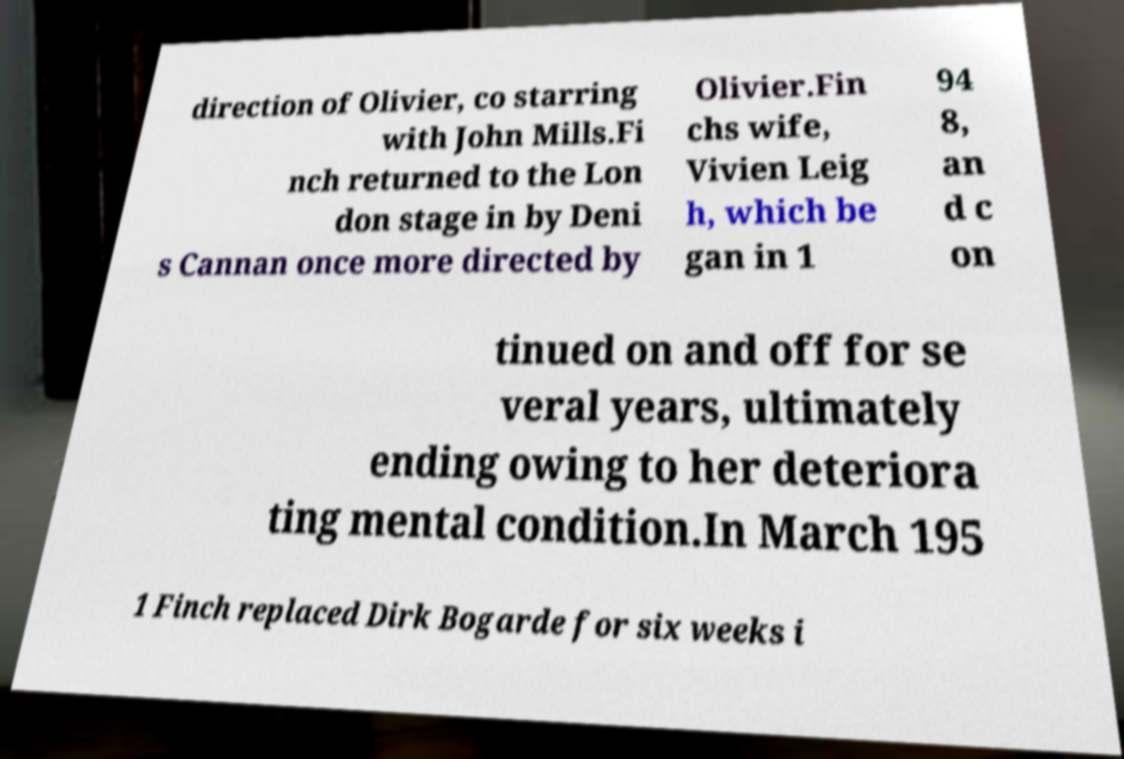There's text embedded in this image that I need extracted. Can you transcribe it verbatim? direction of Olivier, co starring with John Mills.Fi nch returned to the Lon don stage in by Deni s Cannan once more directed by Olivier.Fin chs wife, Vivien Leig h, which be gan in 1 94 8, an d c on tinued on and off for se veral years, ultimately ending owing to her deteriora ting mental condition.In March 195 1 Finch replaced Dirk Bogarde for six weeks i 